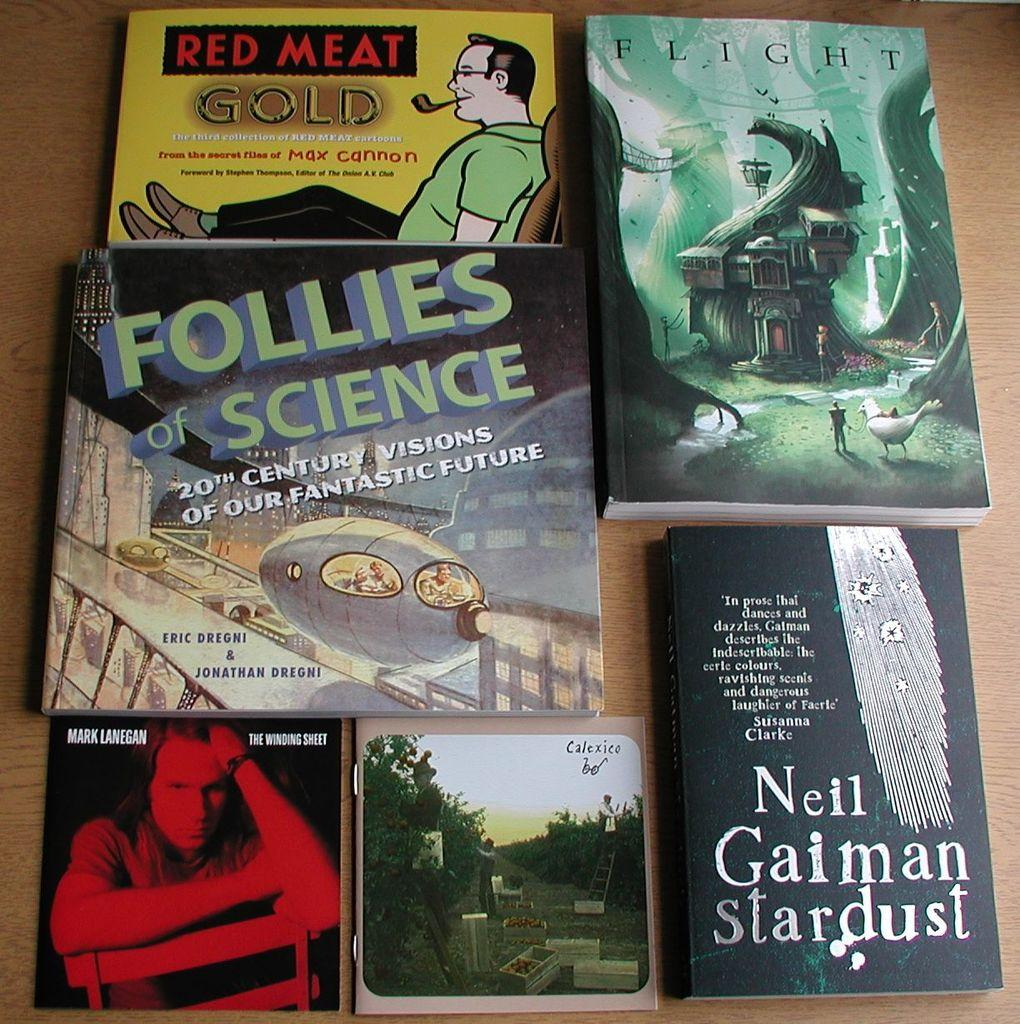<image>
Write a terse but informative summary of the picture. 6 books displayed on the table from different authors 